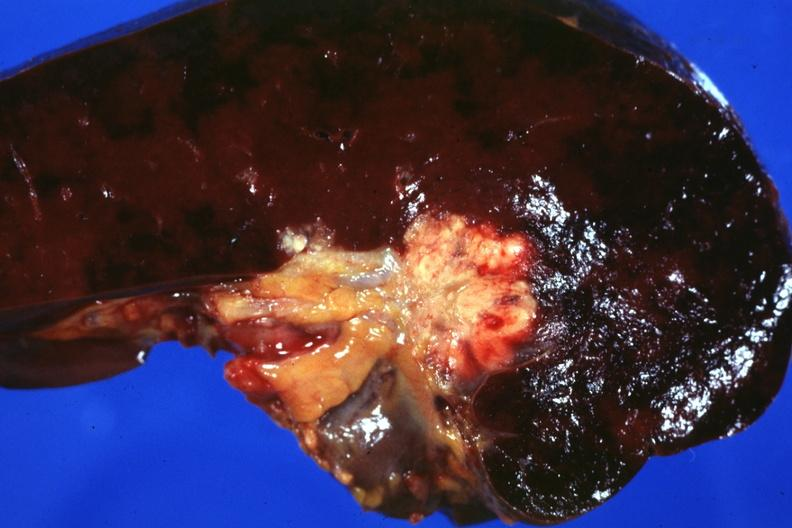what is present?
Answer the question using a single word or phrase. Metastatic colon carcinoma 